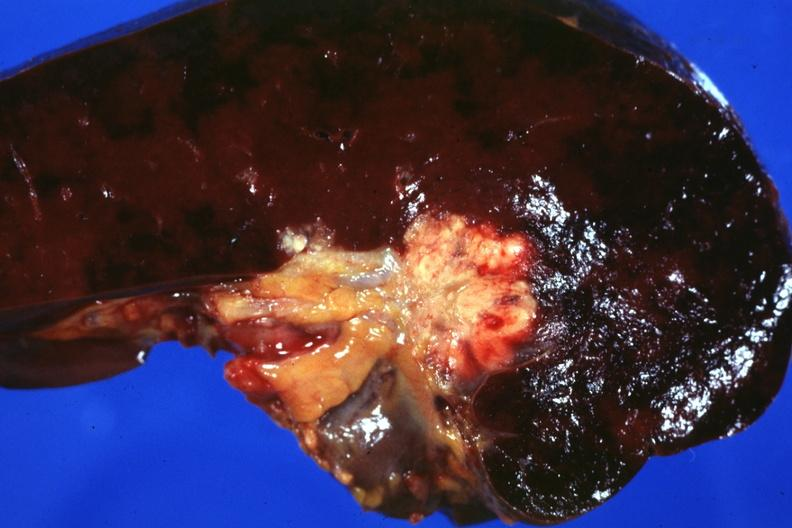what is present?
Answer the question using a single word or phrase. Metastatic colon carcinoma 